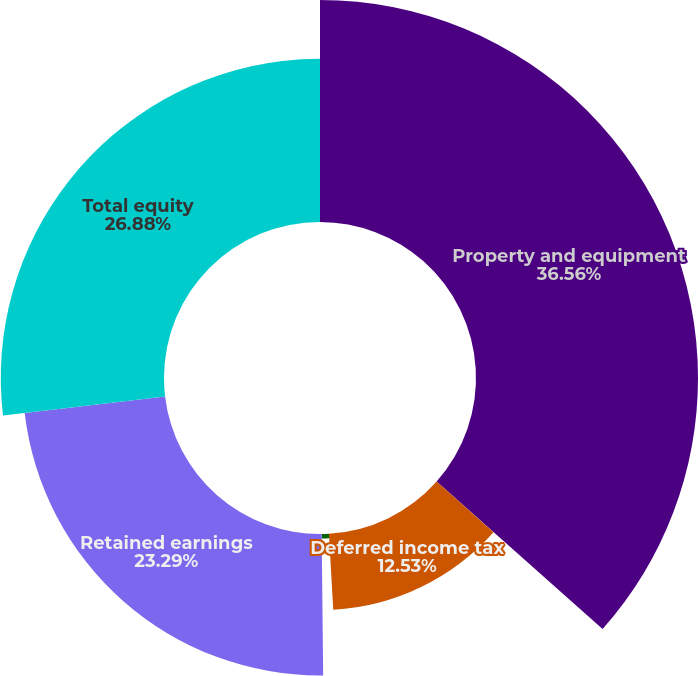Convert chart. <chart><loc_0><loc_0><loc_500><loc_500><pie_chart><fcel>Property and equipment<fcel>Deferred income tax<fcel>Other noncurrent liabilities<fcel>Retained earnings<fcel>Total equity<nl><fcel>36.56%<fcel>12.53%<fcel>0.74%<fcel>23.29%<fcel>26.88%<nl></chart> 